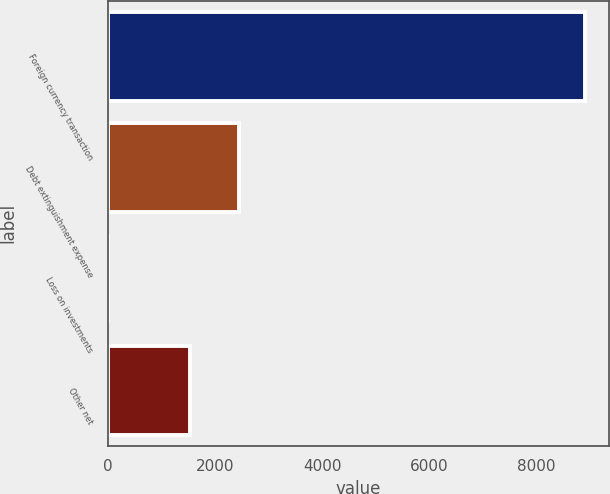Convert chart to OTSL. <chart><loc_0><loc_0><loc_500><loc_500><bar_chart><fcel>Foreign currency transaction<fcel>Debt extinguishment expense<fcel>Loss on investments<fcel>Other net<nl><fcel>8915<fcel>2454<fcel>3.72<fcel>1527<nl></chart> 